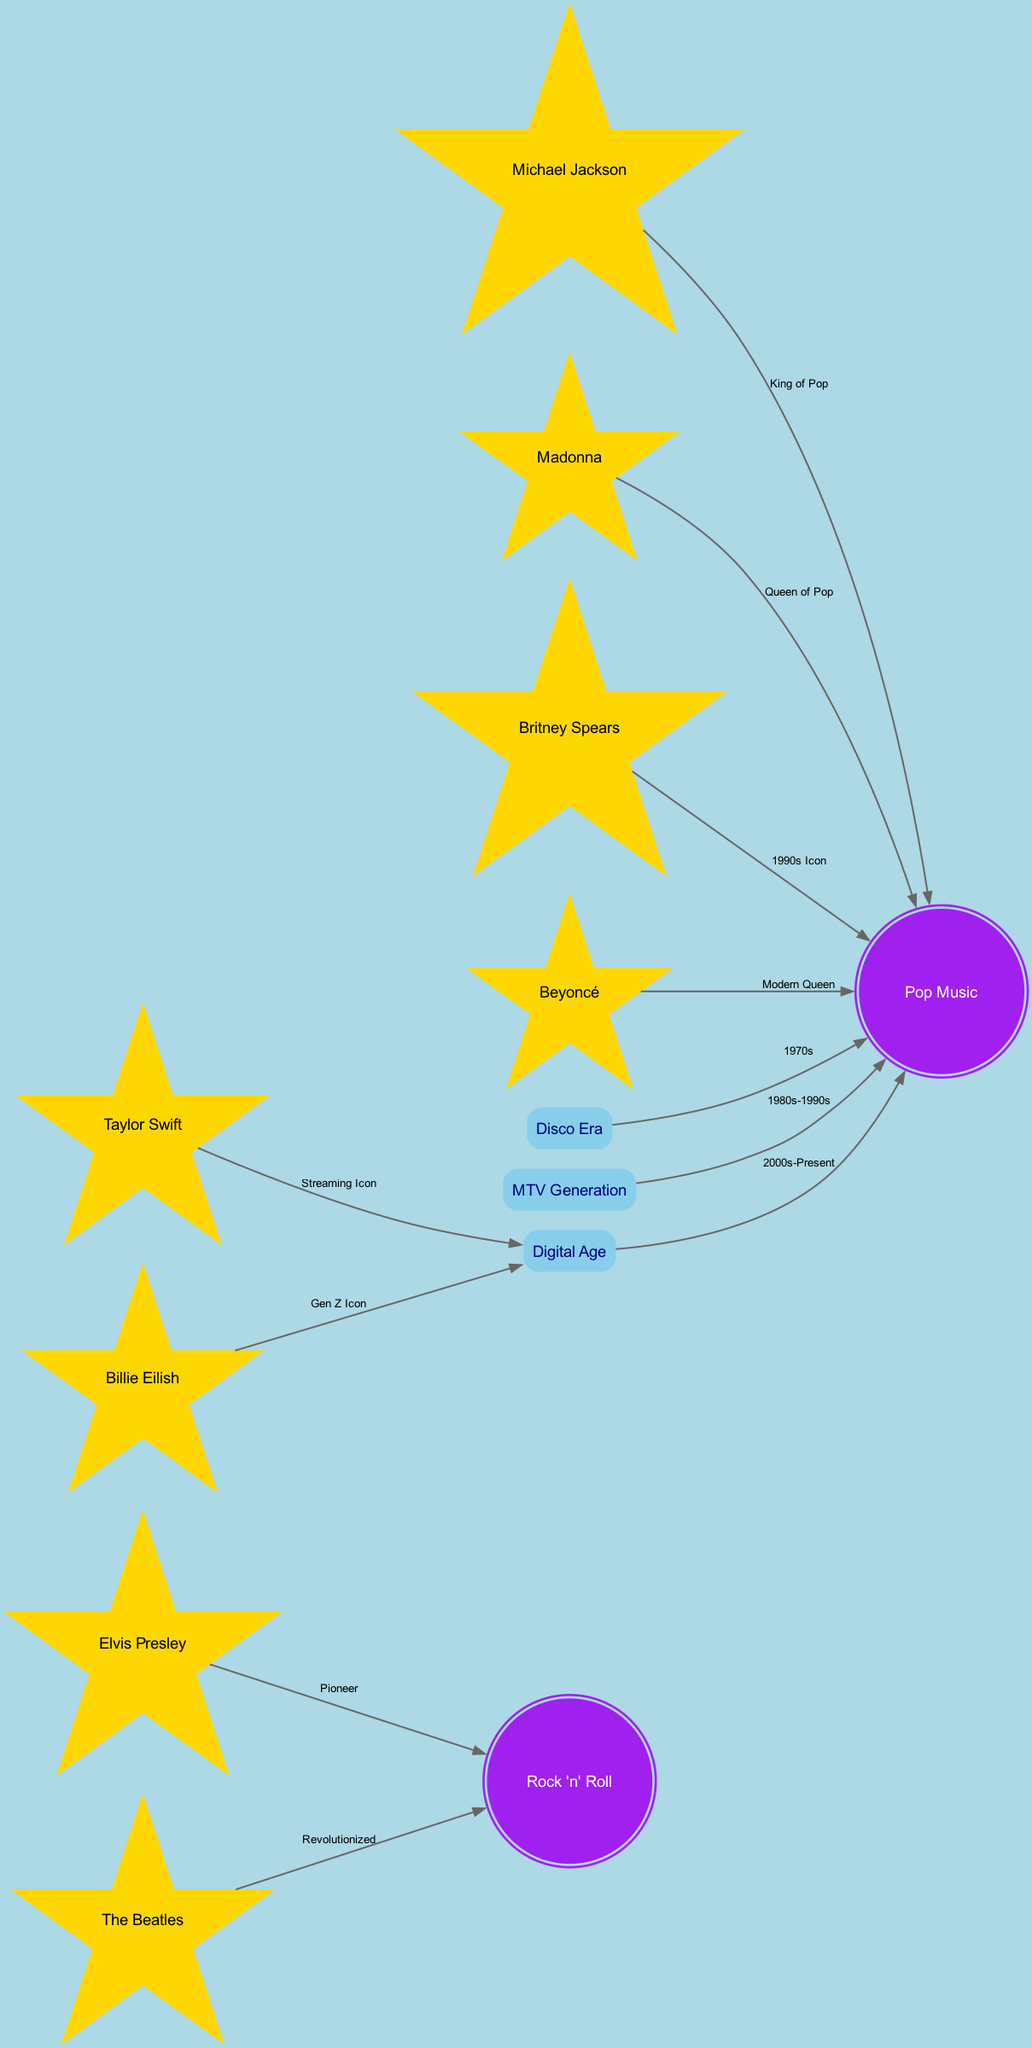What type of node is Billie Eilish? Billie Eilish is categorized as a "star" type in the diagram, which is specifically indicated in the node type of the data provided.
Answer: star How many nodes are there in total? By counting each node in the provided data, there are a total of 12 nodes represented in the diagram, including stars, galaxies, and constellations.
Answer: 12 Who is labeled as the "Queen of Pop"? The diagram identifies Madonna as the "Queen of Pop," which is stated in the edge label connecting her to the Pop Music galaxy.
Answer: Madonna How many edges connect stars to the Pop Music galaxy? There are 5 edges connecting different stars to the Pop Music galaxy, specifically from Michael Jackson, Madonna, Britney Spears, Beyoncé, and the Disco Era constellation.
Answer: 5 What relationship does Elvis Presley have with Rock 'n' Roll? Elvis Presley is connected to Rock 'n' Roll with the label "Pioneer," indicating his significant influence in the genre.
Answer: Pioneer Which star has a direct connection to the Digital Age constellation? Taylor Swift and Billie Eilish both have direct connections to the Digital Age constellation, meaning they are pivotal figures within that era of music.
Answer: Taylor Swift, Billie Eilish What decade is indicated for the Disco Era? The Disco Era is associated with the decade of the 1970s, as clearly noted in the edge connecting it to the Pop Music galaxy.
Answer: 1970s What is the main genre associated with the Beatles? The Beatles are associated with the Rock 'n' Roll galaxy as indicated by their connecting edge, highlighting their revolutionary impact on this genre.
Answer: Rock 'n' Roll In what era is Taylor Swift described as a "Streaming Icon"? Taylor Swift is described as a "Streaming Icon" within the Digital Age constellation, which indicates her influence during this current technological era.
Answer: Digital Age What does the MTV Generation constellation represent? The MTV Generation constellation represents the period from the 1980s to the 1990s, as denoted in its connection to the Pop Music galaxy.
Answer: 1980s-1990s 